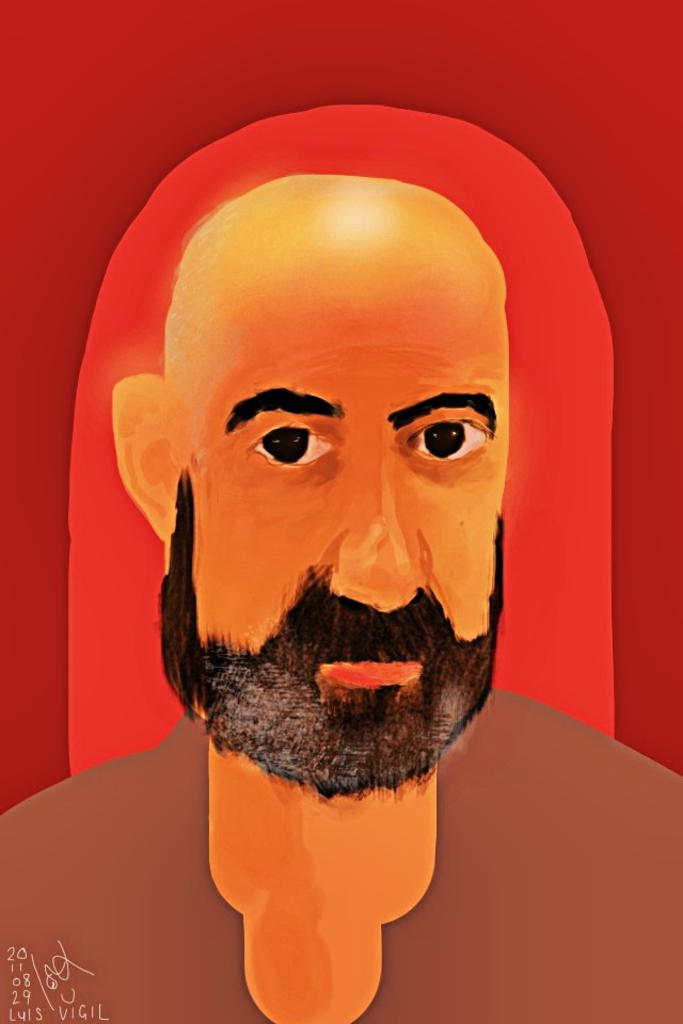What is depicted in the painting in the image? The painting in the image contains a man. Are there any additional elements in the image besides the painting? Yes, there are numbers in the left corner of the image. What type of shade does the goat prefer in the image? There is no goat present in the image, so it is not possible to determine its preferred shade. 